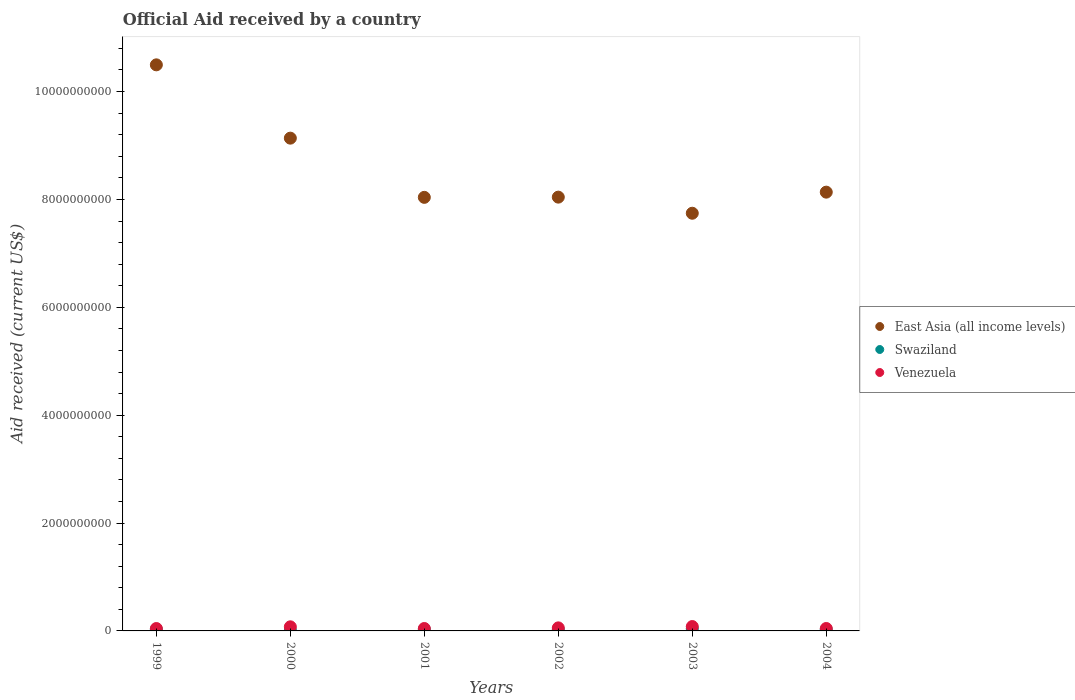What is the net official aid received in Venezuela in 2002?
Offer a very short reply. 5.65e+07. Across all years, what is the maximum net official aid received in Swaziland?
Provide a short and direct response. 4.01e+07. Across all years, what is the minimum net official aid received in Swaziland?
Make the answer very short. 1.31e+07. In which year was the net official aid received in Swaziland maximum?
Give a very brief answer. 2003. In which year was the net official aid received in Swaziland minimum?
Provide a succinct answer. 2000. What is the total net official aid received in Swaziland in the graph?
Your answer should be very brief. 1.59e+08. What is the difference between the net official aid received in East Asia (all income levels) in 1999 and that in 2000?
Your answer should be compact. 1.36e+09. What is the difference between the net official aid received in Venezuela in 2004 and the net official aid received in Swaziland in 1999?
Provide a short and direct response. 1.59e+07. What is the average net official aid received in East Asia (all income levels) per year?
Your answer should be very brief. 8.60e+09. In the year 2000, what is the difference between the net official aid received in East Asia (all income levels) and net official aid received in Venezuela?
Your answer should be compact. 9.06e+09. What is the ratio of the net official aid received in East Asia (all income levels) in 2001 to that in 2004?
Offer a very short reply. 0.99. Is the difference between the net official aid received in East Asia (all income levels) in 2000 and 2002 greater than the difference between the net official aid received in Venezuela in 2000 and 2002?
Your response must be concise. Yes. What is the difference between the highest and the second highest net official aid received in East Asia (all income levels)?
Offer a terse response. 1.36e+09. What is the difference between the highest and the lowest net official aid received in Swaziland?
Your answer should be very brief. 2.70e+07. Is the sum of the net official aid received in Venezuela in 2000 and 2004 greater than the maximum net official aid received in East Asia (all income levels) across all years?
Your response must be concise. No. Is the net official aid received in Venezuela strictly greater than the net official aid received in East Asia (all income levels) over the years?
Offer a terse response. No. Is the net official aid received in East Asia (all income levels) strictly less than the net official aid received in Swaziland over the years?
Make the answer very short. No. How many dotlines are there?
Offer a very short reply. 3. How many years are there in the graph?
Keep it short and to the point. 6. What is the difference between two consecutive major ticks on the Y-axis?
Offer a terse response. 2.00e+09. Does the graph contain any zero values?
Your answer should be compact. No. Does the graph contain grids?
Keep it short and to the point. No. Where does the legend appear in the graph?
Provide a succinct answer. Center right. How are the legend labels stacked?
Offer a very short reply. Vertical. What is the title of the graph?
Your answer should be compact. Official Aid received by a country. What is the label or title of the Y-axis?
Offer a terse response. Aid received (current US$). What is the Aid received (current US$) in East Asia (all income levels) in 1999?
Your answer should be compact. 1.05e+1. What is the Aid received (current US$) in Swaziland in 1999?
Your answer should be very brief. 2.90e+07. What is the Aid received (current US$) in Venezuela in 1999?
Provide a succinct answer. 4.42e+07. What is the Aid received (current US$) of East Asia (all income levels) in 2000?
Provide a succinct answer. 9.14e+09. What is the Aid received (current US$) in Swaziland in 2000?
Ensure brevity in your answer.  1.31e+07. What is the Aid received (current US$) of Venezuela in 2000?
Offer a very short reply. 7.61e+07. What is the Aid received (current US$) of East Asia (all income levels) in 2001?
Your response must be concise. 8.04e+09. What is the Aid received (current US$) of Swaziland in 2001?
Offer a terse response. 2.92e+07. What is the Aid received (current US$) of Venezuela in 2001?
Make the answer very short. 4.47e+07. What is the Aid received (current US$) in East Asia (all income levels) in 2002?
Offer a very short reply. 8.04e+09. What is the Aid received (current US$) of Swaziland in 2002?
Make the answer very short. 2.23e+07. What is the Aid received (current US$) in Venezuela in 2002?
Your response must be concise. 5.65e+07. What is the Aid received (current US$) in East Asia (all income levels) in 2003?
Offer a terse response. 7.74e+09. What is the Aid received (current US$) in Swaziland in 2003?
Provide a short and direct response. 4.01e+07. What is the Aid received (current US$) in Venezuela in 2003?
Provide a succinct answer. 8.11e+07. What is the Aid received (current US$) of East Asia (all income levels) in 2004?
Give a very brief answer. 8.13e+09. What is the Aid received (current US$) of Swaziland in 2004?
Provide a succinct answer. 2.49e+07. What is the Aid received (current US$) in Venezuela in 2004?
Provide a short and direct response. 4.49e+07. Across all years, what is the maximum Aid received (current US$) in East Asia (all income levels)?
Make the answer very short. 1.05e+1. Across all years, what is the maximum Aid received (current US$) of Swaziland?
Provide a short and direct response. 4.01e+07. Across all years, what is the maximum Aid received (current US$) in Venezuela?
Keep it short and to the point. 8.11e+07. Across all years, what is the minimum Aid received (current US$) in East Asia (all income levels)?
Ensure brevity in your answer.  7.74e+09. Across all years, what is the minimum Aid received (current US$) in Swaziland?
Offer a terse response. 1.31e+07. Across all years, what is the minimum Aid received (current US$) of Venezuela?
Give a very brief answer. 4.42e+07. What is the total Aid received (current US$) in East Asia (all income levels) in the graph?
Ensure brevity in your answer.  5.16e+1. What is the total Aid received (current US$) of Swaziland in the graph?
Make the answer very short. 1.59e+08. What is the total Aid received (current US$) of Venezuela in the graph?
Ensure brevity in your answer.  3.48e+08. What is the difference between the Aid received (current US$) of East Asia (all income levels) in 1999 and that in 2000?
Make the answer very short. 1.36e+09. What is the difference between the Aid received (current US$) in Swaziland in 1999 and that in 2000?
Offer a very short reply. 1.59e+07. What is the difference between the Aid received (current US$) of Venezuela in 1999 and that in 2000?
Give a very brief answer. -3.18e+07. What is the difference between the Aid received (current US$) in East Asia (all income levels) in 1999 and that in 2001?
Provide a short and direct response. 2.46e+09. What is the difference between the Aid received (current US$) of Swaziland in 1999 and that in 2001?
Give a very brief answer. -1.60e+05. What is the difference between the Aid received (current US$) in Venezuela in 1999 and that in 2001?
Make the answer very short. -4.50e+05. What is the difference between the Aid received (current US$) of East Asia (all income levels) in 1999 and that in 2002?
Keep it short and to the point. 2.45e+09. What is the difference between the Aid received (current US$) in Swaziland in 1999 and that in 2002?
Your answer should be compact. 6.69e+06. What is the difference between the Aid received (current US$) in Venezuela in 1999 and that in 2002?
Keep it short and to the point. -1.23e+07. What is the difference between the Aid received (current US$) in East Asia (all income levels) in 1999 and that in 2003?
Keep it short and to the point. 2.75e+09. What is the difference between the Aid received (current US$) in Swaziland in 1999 and that in 2003?
Offer a terse response. -1.11e+07. What is the difference between the Aid received (current US$) in Venezuela in 1999 and that in 2003?
Give a very brief answer. -3.69e+07. What is the difference between the Aid received (current US$) in East Asia (all income levels) in 1999 and that in 2004?
Offer a terse response. 2.36e+09. What is the difference between the Aid received (current US$) in Swaziland in 1999 and that in 2004?
Give a very brief answer. 4.10e+06. What is the difference between the Aid received (current US$) in Venezuela in 1999 and that in 2004?
Give a very brief answer. -6.80e+05. What is the difference between the Aid received (current US$) in East Asia (all income levels) in 2000 and that in 2001?
Provide a succinct answer. 1.10e+09. What is the difference between the Aid received (current US$) in Swaziland in 2000 and that in 2001?
Keep it short and to the point. -1.60e+07. What is the difference between the Aid received (current US$) of Venezuela in 2000 and that in 2001?
Provide a succinct answer. 3.14e+07. What is the difference between the Aid received (current US$) of East Asia (all income levels) in 2000 and that in 2002?
Provide a succinct answer. 1.09e+09. What is the difference between the Aid received (current US$) in Swaziland in 2000 and that in 2002?
Your answer should be very brief. -9.17e+06. What is the difference between the Aid received (current US$) of Venezuela in 2000 and that in 2002?
Your answer should be very brief. 1.95e+07. What is the difference between the Aid received (current US$) in East Asia (all income levels) in 2000 and that in 2003?
Give a very brief answer. 1.39e+09. What is the difference between the Aid received (current US$) in Swaziland in 2000 and that in 2003?
Give a very brief answer. -2.70e+07. What is the difference between the Aid received (current US$) of Venezuela in 2000 and that in 2003?
Ensure brevity in your answer.  -5.05e+06. What is the difference between the Aid received (current US$) in East Asia (all income levels) in 2000 and that in 2004?
Your response must be concise. 1.00e+09. What is the difference between the Aid received (current US$) of Swaziland in 2000 and that in 2004?
Keep it short and to the point. -1.18e+07. What is the difference between the Aid received (current US$) in Venezuela in 2000 and that in 2004?
Your answer should be compact. 3.12e+07. What is the difference between the Aid received (current US$) in East Asia (all income levels) in 2001 and that in 2002?
Make the answer very short. -3.97e+06. What is the difference between the Aid received (current US$) in Swaziland in 2001 and that in 2002?
Offer a terse response. 6.85e+06. What is the difference between the Aid received (current US$) of Venezuela in 2001 and that in 2002?
Offer a terse response. -1.18e+07. What is the difference between the Aid received (current US$) of East Asia (all income levels) in 2001 and that in 2003?
Offer a very short reply. 2.95e+08. What is the difference between the Aid received (current US$) of Swaziland in 2001 and that in 2003?
Make the answer very short. -1.09e+07. What is the difference between the Aid received (current US$) in Venezuela in 2001 and that in 2003?
Ensure brevity in your answer.  -3.64e+07. What is the difference between the Aid received (current US$) of East Asia (all income levels) in 2001 and that in 2004?
Offer a terse response. -9.65e+07. What is the difference between the Aid received (current US$) of Swaziland in 2001 and that in 2004?
Ensure brevity in your answer.  4.26e+06. What is the difference between the Aid received (current US$) in East Asia (all income levels) in 2002 and that in 2003?
Your answer should be compact. 2.99e+08. What is the difference between the Aid received (current US$) of Swaziland in 2002 and that in 2003?
Provide a succinct answer. -1.78e+07. What is the difference between the Aid received (current US$) of Venezuela in 2002 and that in 2003?
Offer a very short reply. -2.46e+07. What is the difference between the Aid received (current US$) of East Asia (all income levels) in 2002 and that in 2004?
Offer a very short reply. -9.26e+07. What is the difference between the Aid received (current US$) in Swaziland in 2002 and that in 2004?
Keep it short and to the point. -2.59e+06. What is the difference between the Aid received (current US$) of Venezuela in 2002 and that in 2004?
Your response must be concise. 1.16e+07. What is the difference between the Aid received (current US$) in East Asia (all income levels) in 2003 and that in 2004?
Keep it short and to the point. -3.91e+08. What is the difference between the Aid received (current US$) in Swaziland in 2003 and that in 2004?
Your response must be concise. 1.52e+07. What is the difference between the Aid received (current US$) of Venezuela in 2003 and that in 2004?
Give a very brief answer. 3.62e+07. What is the difference between the Aid received (current US$) in East Asia (all income levels) in 1999 and the Aid received (current US$) in Swaziland in 2000?
Keep it short and to the point. 1.05e+1. What is the difference between the Aid received (current US$) of East Asia (all income levels) in 1999 and the Aid received (current US$) of Venezuela in 2000?
Provide a succinct answer. 1.04e+1. What is the difference between the Aid received (current US$) in Swaziland in 1999 and the Aid received (current US$) in Venezuela in 2000?
Make the answer very short. -4.71e+07. What is the difference between the Aid received (current US$) in East Asia (all income levels) in 1999 and the Aid received (current US$) in Swaziland in 2001?
Make the answer very short. 1.05e+1. What is the difference between the Aid received (current US$) of East Asia (all income levels) in 1999 and the Aid received (current US$) of Venezuela in 2001?
Make the answer very short. 1.05e+1. What is the difference between the Aid received (current US$) of Swaziland in 1999 and the Aid received (current US$) of Venezuela in 2001?
Offer a very short reply. -1.57e+07. What is the difference between the Aid received (current US$) of East Asia (all income levels) in 1999 and the Aid received (current US$) of Swaziland in 2002?
Keep it short and to the point. 1.05e+1. What is the difference between the Aid received (current US$) in East Asia (all income levels) in 1999 and the Aid received (current US$) in Venezuela in 2002?
Your answer should be compact. 1.04e+1. What is the difference between the Aid received (current US$) in Swaziland in 1999 and the Aid received (current US$) in Venezuela in 2002?
Provide a short and direct response. -2.75e+07. What is the difference between the Aid received (current US$) in East Asia (all income levels) in 1999 and the Aid received (current US$) in Swaziland in 2003?
Your response must be concise. 1.05e+1. What is the difference between the Aid received (current US$) of East Asia (all income levels) in 1999 and the Aid received (current US$) of Venezuela in 2003?
Offer a very short reply. 1.04e+1. What is the difference between the Aid received (current US$) in Swaziland in 1999 and the Aid received (current US$) in Venezuela in 2003?
Provide a succinct answer. -5.21e+07. What is the difference between the Aid received (current US$) of East Asia (all income levels) in 1999 and the Aid received (current US$) of Swaziland in 2004?
Your response must be concise. 1.05e+1. What is the difference between the Aid received (current US$) in East Asia (all income levels) in 1999 and the Aid received (current US$) in Venezuela in 2004?
Give a very brief answer. 1.05e+1. What is the difference between the Aid received (current US$) of Swaziland in 1999 and the Aid received (current US$) of Venezuela in 2004?
Your answer should be compact. -1.59e+07. What is the difference between the Aid received (current US$) of East Asia (all income levels) in 2000 and the Aid received (current US$) of Swaziland in 2001?
Offer a very short reply. 9.11e+09. What is the difference between the Aid received (current US$) in East Asia (all income levels) in 2000 and the Aid received (current US$) in Venezuela in 2001?
Provide a succinct answer. 9.09e+09. What is the difference between the Aid received (current US$) in Swaziland in 2000 and the Aid received (current US$) in Venezuela in 2001?
Provide a succinct answer. -3.16e+07. What is the difference between the Aid received (current US$) in East Asia (all income levels) in 2000 and the Aid received (current US$) in Swaziland in 2002?
Offer a very short reply. 9.11e+09. What is the difference between the Aid received (current US$) of East Asia (all income levels) in 2000 and the Aid received (current US$) of Venezuela in 2002?
Keep it short and to the point. 9.08e+09. What is the difference between the Aid received (current US$) of Swaziland in 2000 and the Aid received (current US$) of Venezuela in 2002?
Your answer should be compact. -4.34e+07. What is the difference between the Aid received (current US$) of East Asia (all income levels) in 2000 and the Aid received (current US$) of Swaziland in 2003?
Your response must be concise. 9.10e+09. What is the difference between the Aid received (current US$) of East Asia (all income levels) in 2000 and the Aid received (current US$) of Venezuela in 2003?
Offer a terse response. 9.05e+09. What is the difference between the Aid received (current US$) of Swaziland in 2000 and the Aid received (current US$) of Venezuela in 2003?
Your answer should be compact. -6.80e+07. What is the difference between the Aid received (current US$) in East Asia (all income levels) in 2000 and the Aid received (current US$) in Swaziland in 2004?
Offer a terse response. 9.11e+09. What is the difference between the Aid received (current US$) of East Asia (all income levels) in 2000 and the Aid received (current US$) of Venezuela in 2004?
Offer a very short reply. 9.09e+09. What is the difference between the Aid received (current US$) in Swaziland in 2000 and the Aid received (current US$) in Venezuela in 2004?
Make the answer very short. -3.18e+07. What is the difference between the Aid received (current US$) of East Asia (all income levels) in 2001 and the Aid received (current US$) of Swaziland in 2002?
Offer a very short reply. 8.02e+09. What is the difference between the Aid received (current US$) of East Asia (all income levels) in 2001 and the Aid received (current US$) of Venezuela in 2002?
Your answer should be compact. 7.98e+09. What is the difference between the Aid received (current US$) in Swaziland in 2001 and the Aid received (current US$) in Venezuela in 2002?
Provide a short and direct response. -2.74e+07. What is the difference between the Aid received (current US$) in East Asia (all income levels) in 2001 and the Aid received (current US$) in Swaziland in 2003?
Your answer should be compact. 8.00e+09. What is the difference between the Aid received (current US$) of East Asia (all income levels) in 2001 and the Aid received (current US$) of Venezuela in 2003?
Provide a short and direct response. 7.96e+09. What is the difference between the Aid received (current US$) of Swaziland in 2001 and the Aid received (current US$) of Venezuela in 2003?
Provide a short and direct response. -5.20e+07. What is the difference between the Aid received (current US$) in East Asia (all income levels) in 2001 and the Aid received (current US$) in Swaziland in 2004?
Your response must be concise. 8.01e+09. What is the difference between the Aid received (current US$) in East Asia (all income levels) in 2001 and the Aid received (current US$) in Venezuela in 2004?
Offer a terse response. 7.99e+09. What is the difference between the Aid received (current US$) in Swaziland in 2001 and the Aid received (current US$) in Venezuela in 2004?
Your answer should be very brief. -1.58e+07. What is the difference between the Aid received (current US$) of East Asia (all income levels) in 2002 and the Aid received (current US$) of Swaziland in 2003?
Give a very brief answer. 8.00e+09. What is the difference between the Aid received (current US$) of East Asia (all income levels) in 2002 and the Aid received (current US$) of Venezuela in 2003?
Ensure brevity in your answer.  7.96e+09. What is the difference between the Aid received (current US$) of Swaziland in 2002 and the Aid received (current US$) of Venezuela in 2003?
Your answer should be compact. -5.88e+07. What is the difference between the Aid received (current US$) in East Asia (all income levels) in 2002 and the Aid received (current US$) in Swaziland in 2004?
Offer a terse response. 8.02e+09. What is the difference between the Aid received (current US$) in East Asia (all income levels) in 2002 and the Aid received (current US$) in Venezuela in 2004?
Your answer should be compact. 8.00e+09. What is the difference between the Aid received (current US$) of Swaziland in 2002 and the Aid received (current US$) of Venezuela in 2004?
Give a very brief answer. -2.26e+07. What is the difference between the Aid received (current US$) in East Asia (all income levels) in 2003 and the Aid received (current US$) in Swaziland in 2004?
Give a very brief answer. 7.72e+09. What is the difference between the Aid received (current US$) of East Asia (all income levels) in 2003 and the Aid received (current US$) of Venezuela in 2004?
Provide a short and direct response. 7.70e+09. What is the difference between the Aid received (current US$) in Swaziland in 2003 and the Aid received (current US$) in Venezuela in 2004?
Offer a very short reply. -4.82e+06. What is the average Aid received (current US$) of East Asia (all income levels) per year?
Make the answer very short. 8.60e+09. What is the average Aid received (current US$) of Swaziland per year?
Offer a very short reply. 2.64e+07. What is the average Aid received (current US$) in Venezuela per year?
Provide a short and direct response. 5.79e+07. In the year 1999, what is the difference between the Aid received (current US$) of East Asia (all income levels) and Aid received (current US$) of Swaziland?
Your response must be concise. 1.05e+1. In the year 1999, what is the difference between the Aid received (current US$) of East Asia (all income levels) and Aid received (current US$) of Venezuela?
Ensure brevity in your answer.  1.05e+1. In the year 1999, what is the difference between the Aid received (current US$) in Swaziland and Aid received (current US$) in Venezuela?
Your answer should be very brief. -1.52e+07. In the year 2000, what is the difference between the Aid received (current US$) in East Asia (all income levels) and Aid received (current US$) in Swaziland?
Provide a short and direct response. 9.12e+09. In the year 2000, what is the difference between the Aid received (current US$) in East Asia (all income levels) and Aid received (current US$) in Venezuela?
Your answer should be compact. 9.06e+09. In the year 2000, what is the difference between the Aid received (current US$) in Swaziland and Aid received (current US$) in Venezuela?
Provide a short and direct response. -6.29e+07. In the year 2001, what is the difference between the Aid received (current US$) in East Asia (all income levels) and Aid received (current US$) in Swaziland?
Give a very brief answer. 8.01e+09. In the year 2001, what is the difference between the Aid received (current US$) of East Asia (all income levels) and Aid received (current US$) of Venezuela?
Offer a terse response. 7.99e+09. In the year 2001, what is the difference between the Aid received (current US$) in Swaziland and Aid received (current US$) in Venezuela?
Your response must be concise. -1.55e+07. In the year 2002, what is the difference between the Aid received (current US$) in East Asia (all income levels) and Aid received (current US$) in Swaziland?
Your response must be concise. 8.02e+09. In the year 2002, what is the difference between the Aid received (current US$) of East Asia (all income levels) and Aid received (current US$) of Venezuela?
Your answer should be compact. 7.99e+09. In the year 2002, what is the difference between the Aid received (current US$) of Swaziland and Aid received (current US$) of Venezuela?
Offer a very short reply. -3.42e+07. In the year 2003, what is the difference between the Aid received (current US$) of East Asia (all income levels) and Aid received (current US$) of Swaziland?
Your answer should be compact. 7.70e+09. In the year 2003, what is the difference between the Aid received (current US$) of East Asia (all income levels) and Aid received (current US$) of Venezuela?
Make the answer very short. 7.66e+09. In the year 2003, what is the difference between the Aid received (current US$) in Swaziland and Aid received (current US$) in Venezuela?
Your answer should be very brief. -4.10e+07. In the year 2004, what is the difference between the Aid received (current US$) of East Asia (all income levels) and Aid received (current US$) of Swaziland?
Offer a terse response. 8.11e+09. In the year 2004, what is the difference between the Aid received (current US$) in East Asia (all income levels) and Aid received (current US$) in Venezuela?
Ensure brevity in your answer.  8.09e+09. In the year 2004, what is the difference between the Aid received (current US$) of Swaziland and Aid received (current US$) of Venezuela?
Offer a very short reply. -2.00e+07. What is the ratio of the Aid received (current US$) in East Asia (all income levels) in 1999 to that in 2000?
Give a very brief answer. 1.15. What is the ratio of the Aid received (current US$) in Swaziland in 1999 to that in 2000?
Ensure brevity in your answer.  2.21. What is the ratio of the Aid received (current US$) of Venezuela in 1999 to that in 2000?
Give a very brief answer. 0.58. What is the ratio of the Aid received (current US$) in East Asia (all income levels) in 1999 to that in 2001?
Provide a short and direct response. 1.31. What is the ratio of the Aid received (current US$) of Swaziland in 1999 to that in 2001?
Provide a succinct answer. 0.99. What is the ratio of the Aid received (current US$) of Venezuela in 1999 to that in 2001?
Keep it short and to the point. 0.99. What is the ratio of the Aid received (current US$) of East Asia (all income levels) in 1999 to that in 2002?
Offer a terse response. 1.3. What is the ratio of the Aid received (current US$) of Venezuela in 1999 to that in 2002?
Keep it short and to the point. 0.78. What is the ratio of the Aid received (current US$) of East Asia (all income levels) in 1999 to that in 2003?
Give a very brief answer. 1.36. What is the ratio of the Aid received (current US$) of Swaziland in 1999 to that in 2003?
Keep it short and to the point. 0.72. What is the ratio of the Aid received (current US$) of Venezuela in 1999 to that in 2003?
Your answer should be very brief. 0.55. What is the ratio of the Aid received (current US$) in East Asia (all income levels) in 1999 to that in 2004?
Make the answer very short. 1.29. What is the ratio of the Aid received (current US$) in Swaziland in 1999 to that in 2004?
Provide a short and direct response. 1.16. What is the ratio of the Aid received (current US$) in Venezuela in 1999 to that in 2004?
Provide a succinct answer. 0.98. What is the ratio of the Aid received (current US$) of East Asia (all income levels) in 2000 to that in 2001?
Make the answer very short. 1.14. What is the ratio of the Aid received (current US$) of Swaziland in 2000 to that in 2001?
Provide a short and direct response. 0.45. What is the ratio of the Aid received (current US$) of Venezuela in 2000 to that in 2001?
Provide a short and direct response. 1.7. What is the ratio of the Aid received (current US$) in East Asia (all income levels) in 2000 to that in 2002?
Ensure brevity in your answer.  1.14. What is the ratio of the Aid received (current US$) in Swaziland in 2000 to that in 2002?
Offer a terse response. 0.59. What is the ratio of the Aid received (current US$) in Venezuela in 2000 to that in 2002?
Offer a terse response. 1.35. What is the ratio of the Aid received (current US$) of East Asia (all income levels) in 2000 to that in 2003?
Give a very brief answer. 1.18. What is the ratio of the Aid received (current US$) of Swaziland in 2000 to that in 2003?
Provide a short and direct response. 0.33. What is the ratio of the Aid received (current US$) of Venezuela in 2000 to that in 2003?
Your answer should be very brief. 0.94. What is the ratio of the Aid received (current US$) of East Asia (all income levels) in 2000 to that in 2004?
Your response must be concise. 1.12. What is the ratio of the Aid received (current US$) in Swaziland in 2000 to that in 2004?
Make the answer very short. 0.53. What is the ratio of the Aid received (current US$) of Venezuela in 2000 to that in 2004?
Your answer should be very brief. 1.69. What is the ratio of the Aid received (current US$) in East Asia (all income levels) in 2001 to that in 2002?
Your response must be concise. 1. What is the ratio of the Aid received (current US$) of Swaziland in 2001 to that in 2002?
Your response must be concise. 1.31. What is the ratio of the Aid received (current US$) in Venezuela in 2001 to that in 2002?
Your answer should be compact. 0.79. What is the ratio of the Aid received (current US$) of East Asia (all income levels) in 2001 to that in 2003?
Keep it short and to the point. 1.04. What is the ratio of the Aid received (current US$) in Swaziland in 2001 to that in 2003?
Your answer should be compact. 0.73. What is the ratio of the Aid received (current US$) of Venezuela in 2001 to that in 2003?
Provide a succinct answer. 0.55. What is the ratio of the Aid received (current US$) of Swaziland in 2001 to that in 2004?
Your answer should be very brief. 1.17. What is the ratio of the Aid received (current US$) in East Asia (all income levels) in 2002 to that in 2003?
Offer a very short reply. 1.04. What is the ratio of the Aid received (current US$) in Swaziland in 2002 to that in 2003?
Keep it short and to the point. 0.56. What is the ratio of the Aid received (current US$) of Venezuela in 2002 to that in 2003?
Keep it short and to the point. 0.7. What is the ratio of the Aid received (current US$) in East Asia (all income levels) in 2002 to that in 2004?
Ensure brevity in your answer.  0.99. What is the ratio of the Aid received (current US$) of Swaziland in 2002 to that in 2004?
Provide a short and direct response. 0.9. What is the ratio of the Aid received (current US$) of Venezuela in 2002 to that in 2004?
Ensure brevity in your answer.  1.26. What is the ratio of the Aid received (current US$) in East Asia (all income levels) in 2003 to that in 2004?
Your answer should be very brief. 0.95. What is the ratio of the Aid received (current US$) of Swaziland in 2003 to that in 2004?
Ensure brevity in your answer.  1.61. What is the ratio of the Aid received (current US$) in Venezuela in 2003 to that in 2004?
Your response must be concise. 1.81. What is the difference between the highest and the second highest Aid received (current US$) of East Asia (all income levels)?
Ensure brevity in your answer.  1.36e+09. What is the difference between the highest and the second highest Aid received (current US$) of Swaziland?
Your answer should be very brief. 1.09e+07. What is the difference between the highest and the second highest Aid received (current US$) of Venezuela?
Offer a terse response. 5.05e+06. What is the difference between the highest and the lowest Aid received (current US$) of East Asia (all income levels)?
Make the answer very short. 2.75e+09. What is the difference between the highest and the lowest Aid received (current US$) of Swaziland?
Your answer should be very brief. 2.70e+07. What is the difference between the highest and the lowest Aid received (current US$) of Venezuela?
Offer a very short reply. 3.69e+07. 